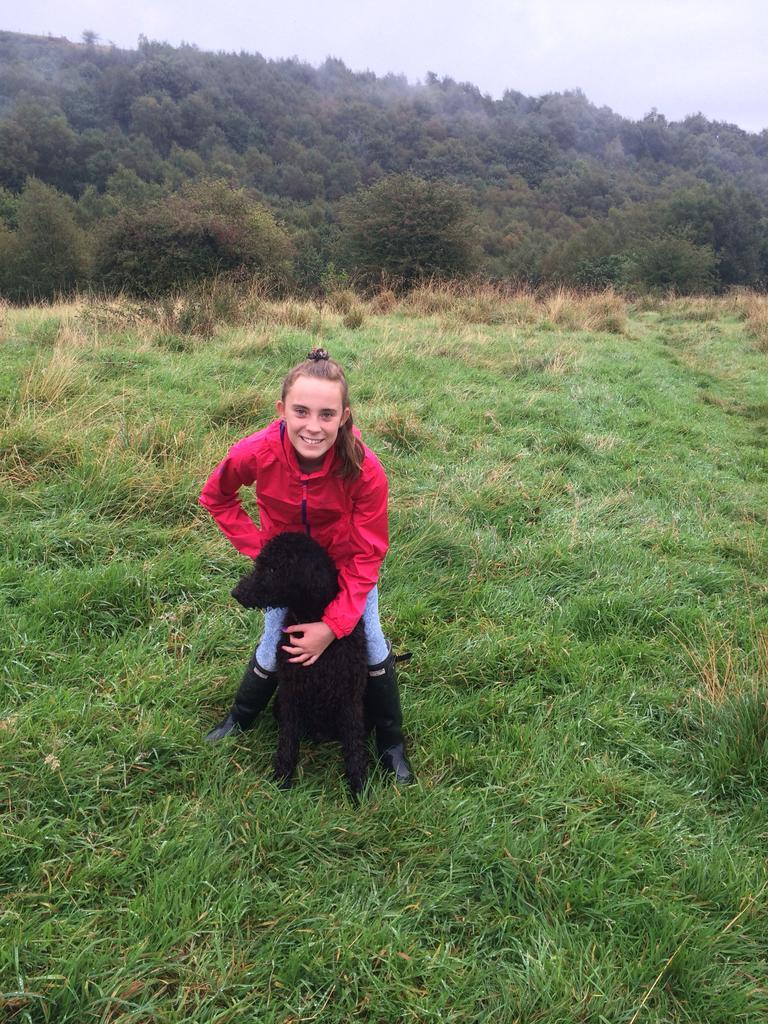In one or two sentences, can you explain what this image depicts? This person sitting and holding animal and smiling,behind this person person we can see trees,sky. This is grass. 